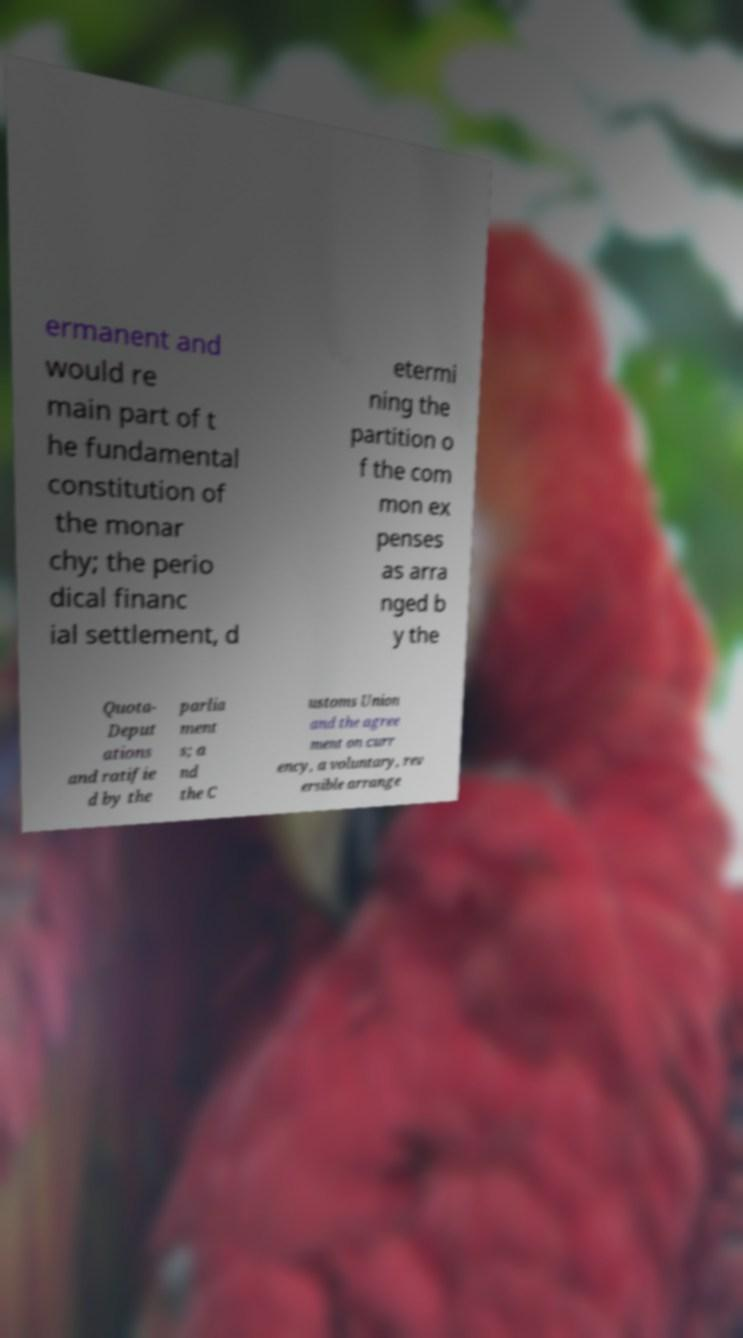Please identify and transcribe the text found in this image. ermanent and would re main part of t he fundamental constitution of the monar chy; the perio dical financ ial settlement, d etermi ning the partition o f the com mon ex penses as arra nged b y the Quota- Deput ations and ratifie d by the parlia ment s; a nd the C ustoms Union and the agree ment on curr ency, a voluntary, rev ersible arrange 